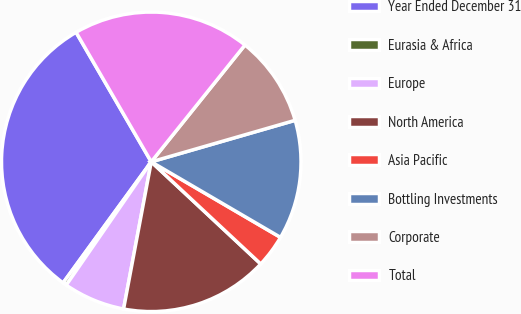Convert chart to OTSL. <chart><loc_0><loc_0><loc_500><loc_500><pie_chart><fcel>Year Ended December 31<fcel>Eurasia & Africa<fcel>Europe<fcel>North America<fcel>Asia Pacific<fcel>Bottling Investments<fcel>Corporate<fcel>Total<nl><fcel>31.61%<fcel>0.41%<fcel>6.65%<fcel>16.01%<fcel>3.53%<fcel>12.89%<fcel>9.77%<fcel>19.13%<nl></chart> 